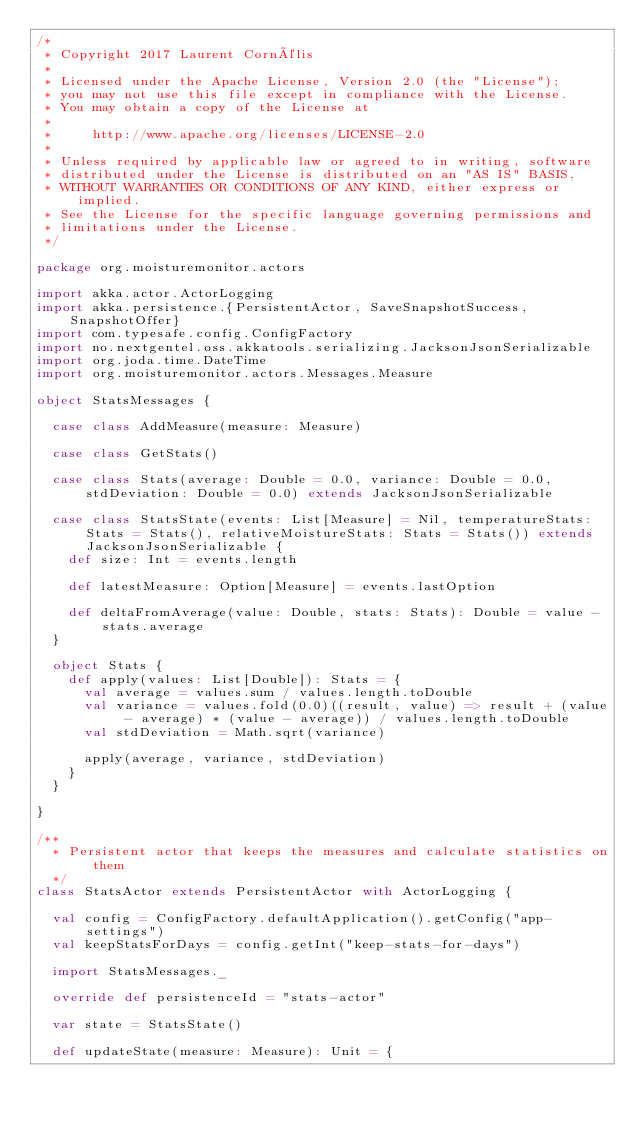<code> <loc_0><loc_0><loc_500><loc_500><_Scala_>/*
 * Copyright 2017 Laurent Cornélis
 *
 * Licensed under the Apache License, Version 2.0 (the "License");
 * you may not use this file except in compliance with the License.
 * You may obtain a copy of the License at
 *
 *     http://www.apache.org/licenses/LICENSE-2.0
 *
 * Unless required by applicable law or agreed to in writing, software
 * distributed under the License is distributed on an "AS IS" BASIS,
 * WITHOUT WARRANTIES OR CONDITIONS OF ANY KIND, either express or implied.
 * See the License for the specific language governing permissions and
 * limitations under the License.
 */

package org.moisturemonitor.actors

import akka.actor.ActorLogging
import akka.persistence.{PersistentActor, SaveSnapshotSuccess, SnapshotOffer}
import com.typesafe.config.ConfigFactory
import no.nextgentel.oss.akkatools.serializing.JacksonJsonSerializable
import org.joda.time.DateTime
import org.moisturemonitor.actors.Messages.Measure

object StatsMessages {

  case class AddMeasure(measure: Measure)

  case class GetStats()

  case class Stats(average: Double = 0.0, variance: Double = 0.0, stdDeviation: Double = 0.0) extends JacksonJsonSerializable

  case class StatsState(events: List[Measure] = Nil, temperatureStats: Stats = Stats(), relativeMoistureStats: Stats = Stats()) extends JacksonJsonSerializable {
    def size: Int = events.length

    def latestMeasure: Option[Measure] = events.lastOption

    def deltaFromAverage(value: Double, stats: Stats): Double = value - stats.average
  }

  object Stats {
    def apply(values: List[Double]): Stats = {
      val average = values.sum / values.length.toDouble
      val variance = values.fold(0.0)((result, value) => result + (value - average) * (value - average)) / values.length.toDouble
      val stdDeviation = Math.sqrt(variance)

      apply(average, variance, stdDeviation)
    }
  }

}

/**
  * Persistent actor that keeps the measures and calculate statistics on them
  */
class StatsActor extends PersistentActor with ActorLogging {

  val config = ConfigFactory.defaultApplication().getConfig("app-settings")
  val keepStatsForDays = config.getInt("keep-stats-for-days")

  import StatsMessages._

  override def persistenceId = "stats-actor"

  var state = StatsState()

  def updateState(measure: Measure): Unit = {</code> 